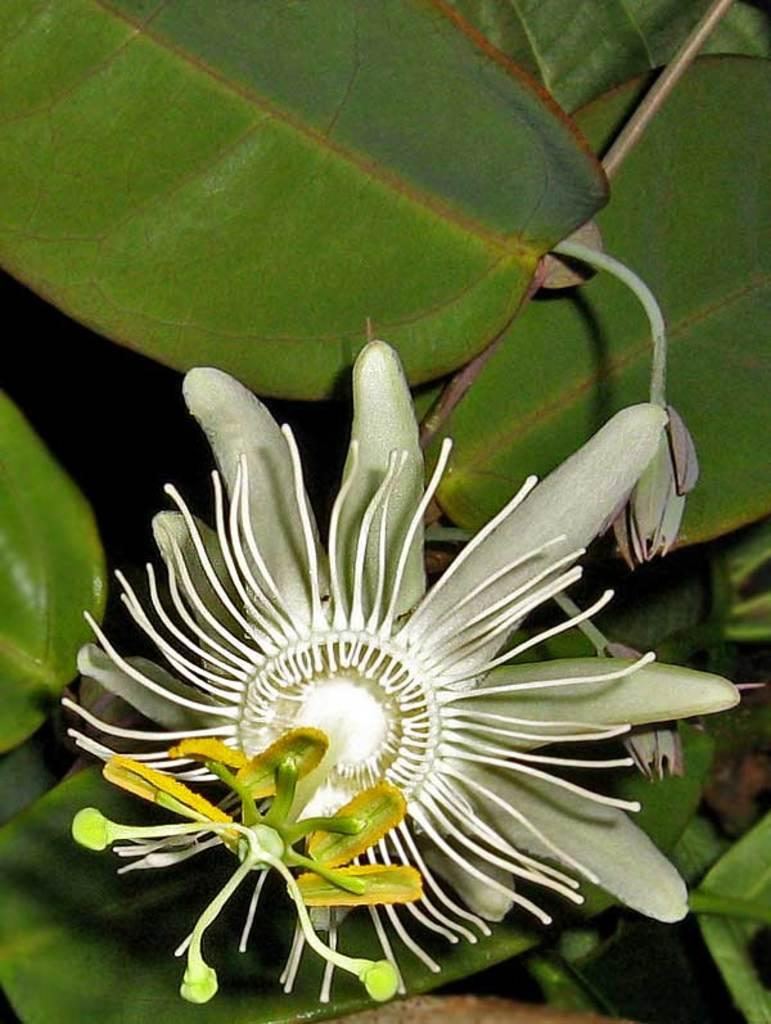What type of plant can be seen in the image? There is a flower in the image. Are there any unopened parts of the flower visible? Yes, there are buds in the image. What other parts of the plant can be seen in the image? There are leaves in the image. What language is spoken by the brain in the image? There is no brain present in the image, as it features a flower, buds, and leaves. 